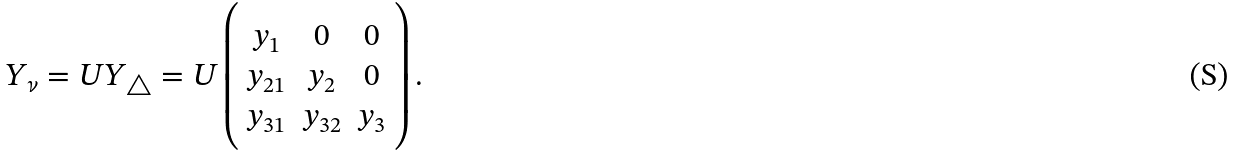Convert formula to latex. <formula><loc_0><loc_0><loc_500><loc_500>Y _ { \nu } = { U } Y _ { \triangle } = { U } \left ( \begin{array} { c c c } { { y _ { 1 } } } & { 0 } & { 0 } \\ { { y _ { 2 1 } } } & { { y _ { 2 } } } & { 0 } \\ { { y _ { 3 1 } } } & { { y _ { 3 2 } } } & { { y _ { 3 } } } \end{array} \right ) .</formula> 